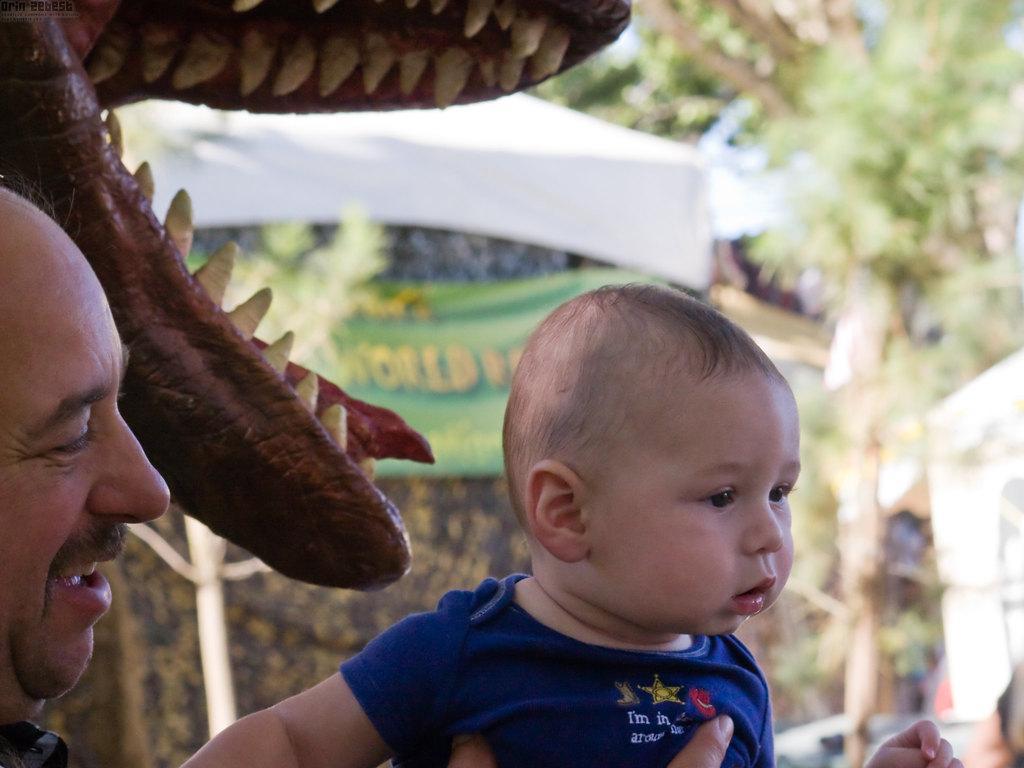Describe this image in one or two sentences. In this image in the foreground there is one person who is holding a boy, and in the background there is a toy and animal, tents and some trees and cars. 